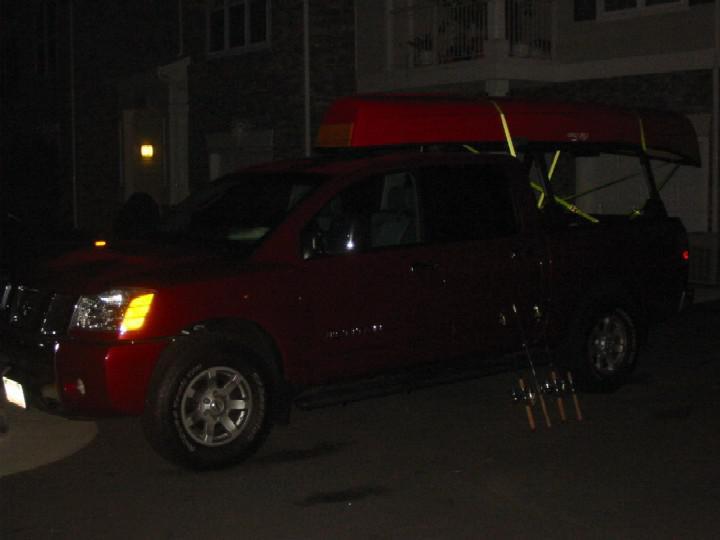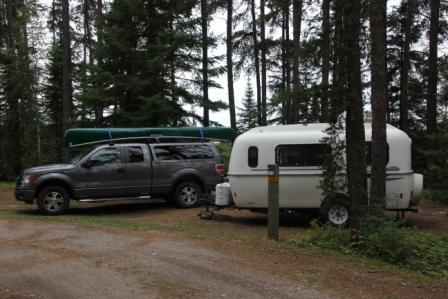The first image is the image on the left, the second image is the image on the right. Given the left and right images, does the statement "In the right image there is a truck driving to the left in the daytime." hold true? Answer yes or no. Yes. 